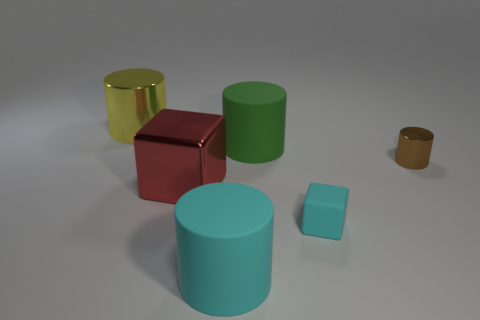Subtract all small brown cylinders. How many cylinders are left? 3 Subtract all green cylinders. How many cylinders are left? 3 Subtract all blocks. How many objects are left? 4 Add 1 large purple matte balls. How many objects exist? 7 Subtract 1 cylinders. How many cylinders are left? 3 Add 5 green matte cylinders. How many green matte cylinders are left? 6 Add 3 brown objects. How many brown objects exist? 4 Subtract 0 purple spheres. How many objects are left? 6 Subtract all blue cylinders. Subtract all cyan blocks. How many cylinders are left? 4 Subtract all blue cylinders. Subtract all small rubber blocks. How many objects are left? 5 